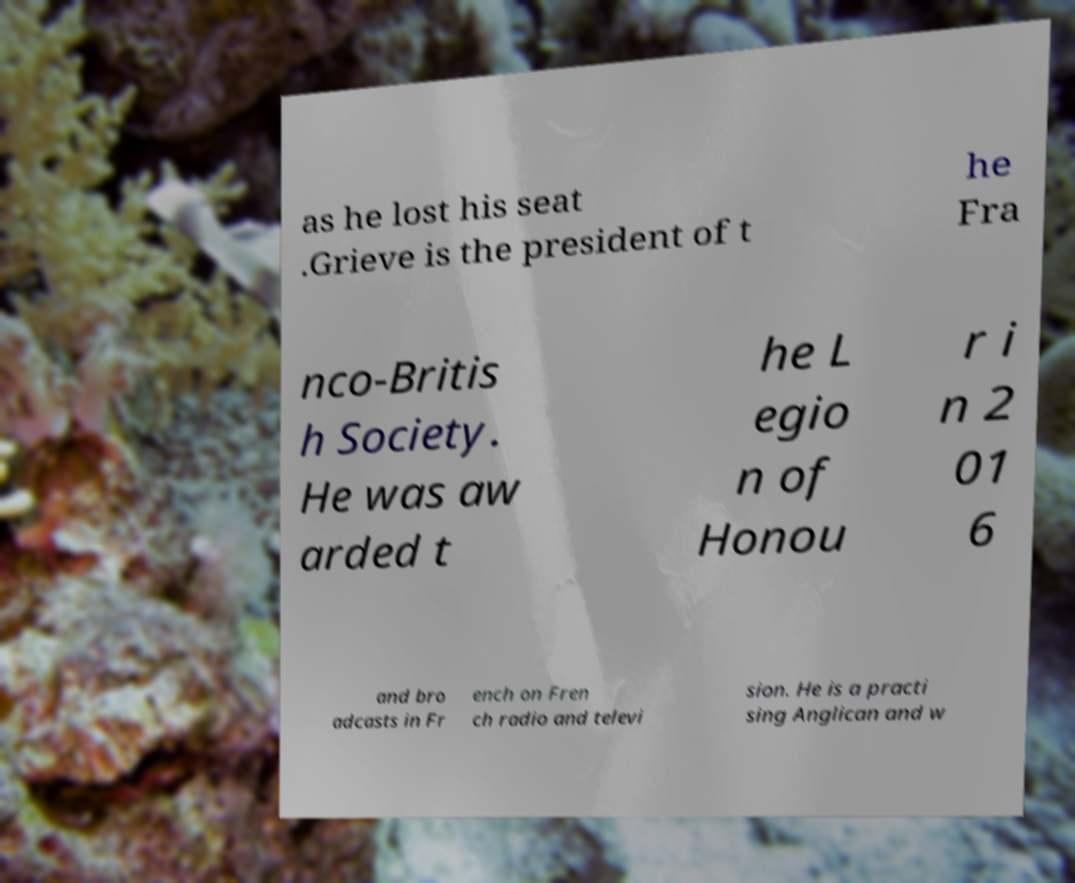What messages or text are displayed in this image? I need them in a readable, typed format. as he lost his seat .Grieve is the president of t he Fra nco-Britis h Society. He was aw arded t he L egio n of Honou r i n 2 01 6 and bro adcasts in Fr ench on Fren ch radio and televi sion. He is a practi sing Anglican and w 